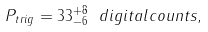<formula> <loc_0><loc_0><loc_500><loc_500>P _ { t r i g } = 3 3 ^ { + 8 } _ { - 6 } \ d i g i t a l c o u n t s ,</formula> 